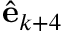<formula> <loc_0><loc_0><loc_500><loc_500>\hat { e } _ { k + 4 }</formula> 